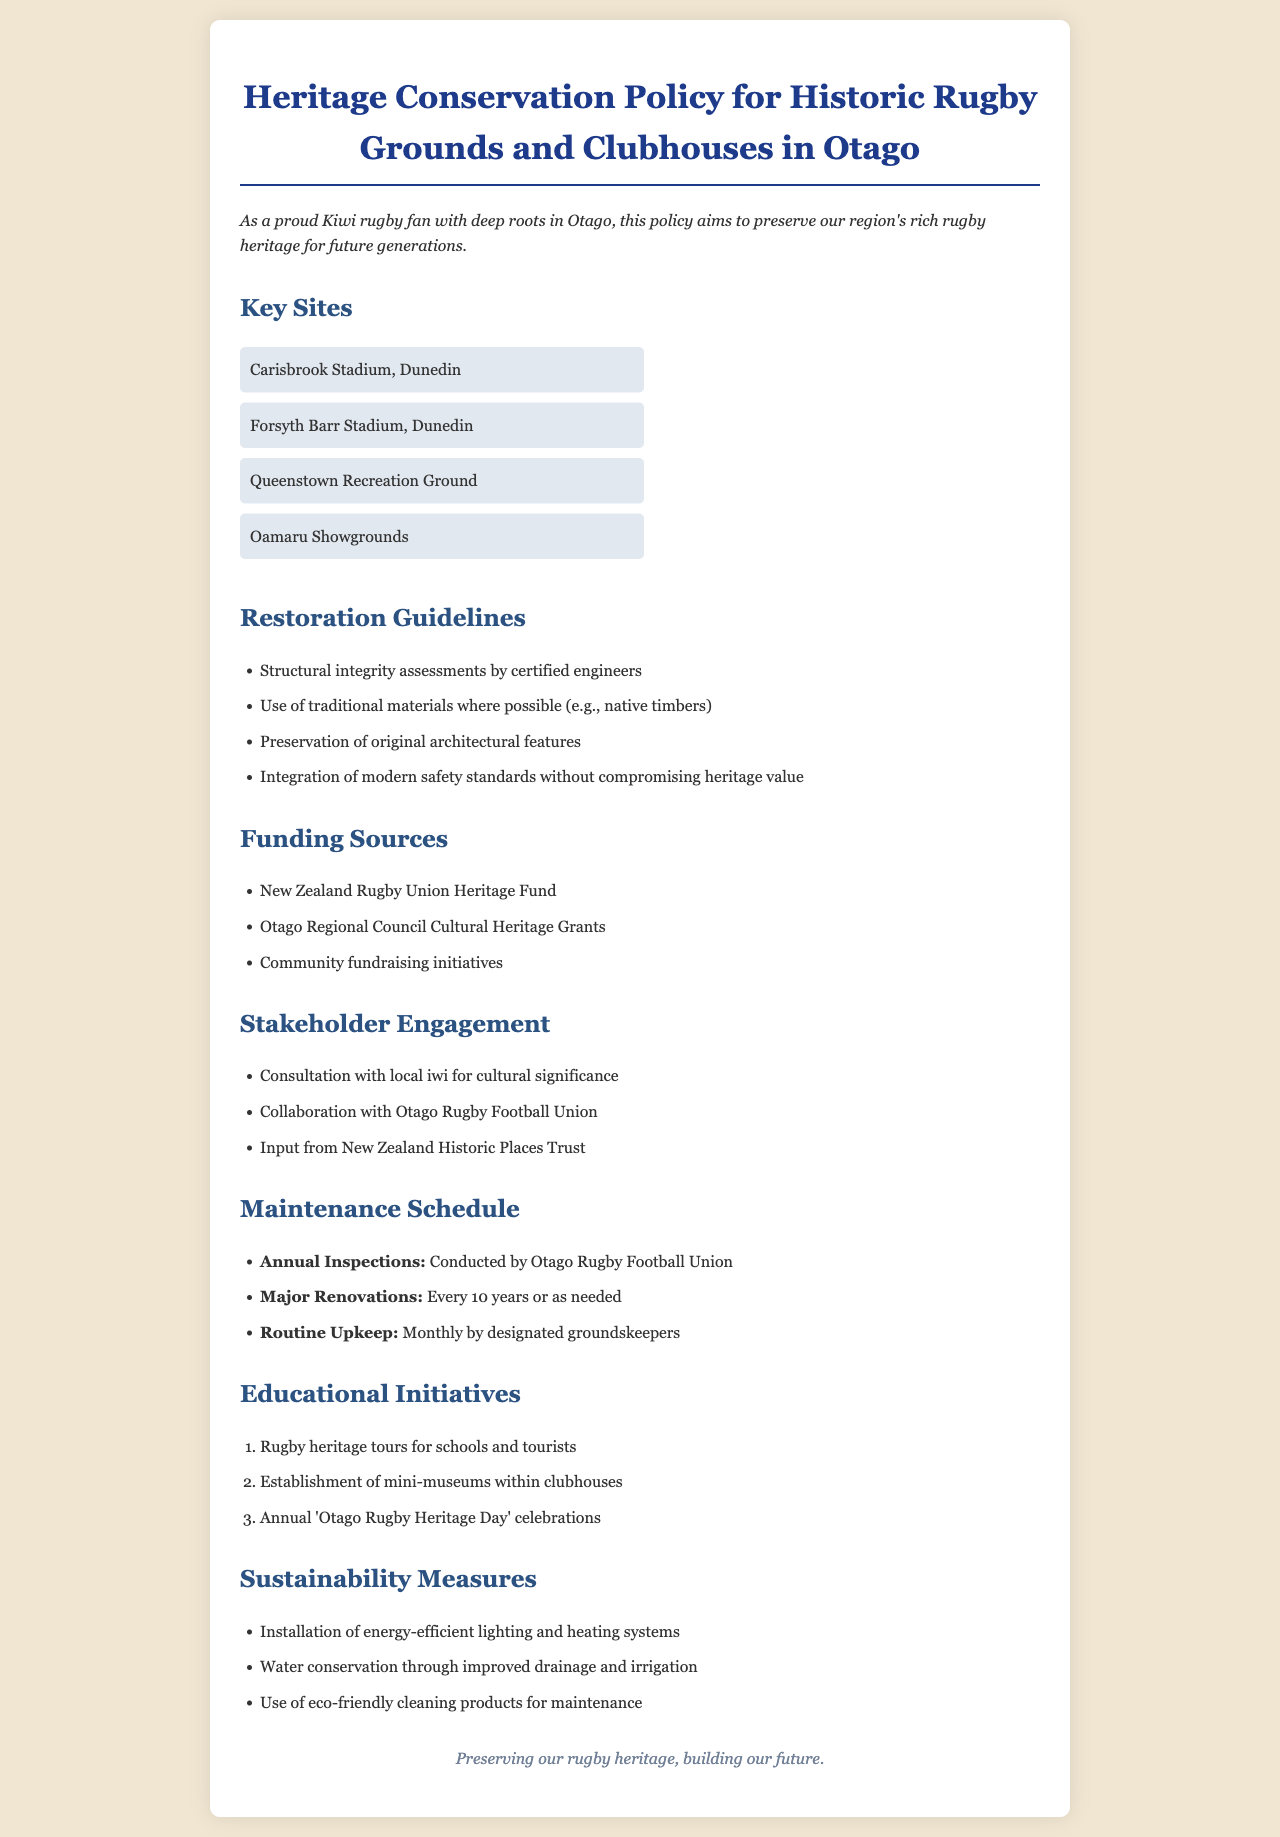What are the key sites mentioned in the document? The key sites include those specifically listed under the "Key Sites" section, which outlines notable rugby locations within Otago.
Answer: Carisbrook Stadium, Forsyth Barr Stadium, Queenstown Recreation Ground, Oamaru Showgrounds What is the purpose of the restoration guidelines? The restoration guidelines aim to ensure the preservation and appropriate restoration of historic rugby grounds and clubhouses in Otago.
Answer: Preservation of heritage How often are major renovations scheduled? The policy outlines a timeline for inspections and renovations, which includes the frequency of major renovations for maintaining the sites.
Answer: Every 10 years Which organization conducts annual inspections? The document specifies the entity responsible for conducting annual inspections of the rugby heritage sites, detailing oversight for preservation.
Answer: Otago Rugby Football Union What is one source of funding for heritage conservation? The document lists various funding sources under the "Funding Sources" section, highlighting avenues available for financial support.
Answer: New Zealand Rugby Union Heritage Fund How are educational initiatives structured in the policy? Educational initiatives are outlined in a section that details various activities designed to promote rugby heritage and involvement in the community.
Answer: Rugby heritage tours, mini-museums, annual celebrations What is one sustainability measure mentioned? The document includes a section on sustainability measures, detailing specific actions taken to ensure environmental responsibility and resource conservation in maintenance.
Answer: Energy-efficient lighting What does the policy aim to preserve? The policy states its goals clearly regarding the historical significance of the rugby facilities and the intent to maintain their integrity for future generations.
Answer: Rugby heritage What is the slogan at the bottom of the document? The document concludes with a phrase that encapsulates its intent, emphasizing the mission for rugby heritage conservation.
Answer: Preserving our rugby heritage, building our future 